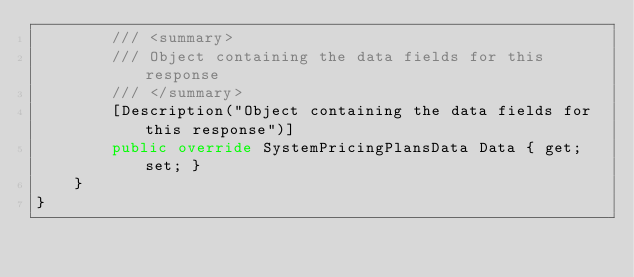<code> <loc_0><loc_0><loc_500><loc_500><_C#_>        /// <summary>
        /// Object containing the data fields for this response
        /// </summary>
        [Description("Object containing the data fields for this response")]
        public override SystemPricingPlansData Data { get; set; }
    }
}</code> 